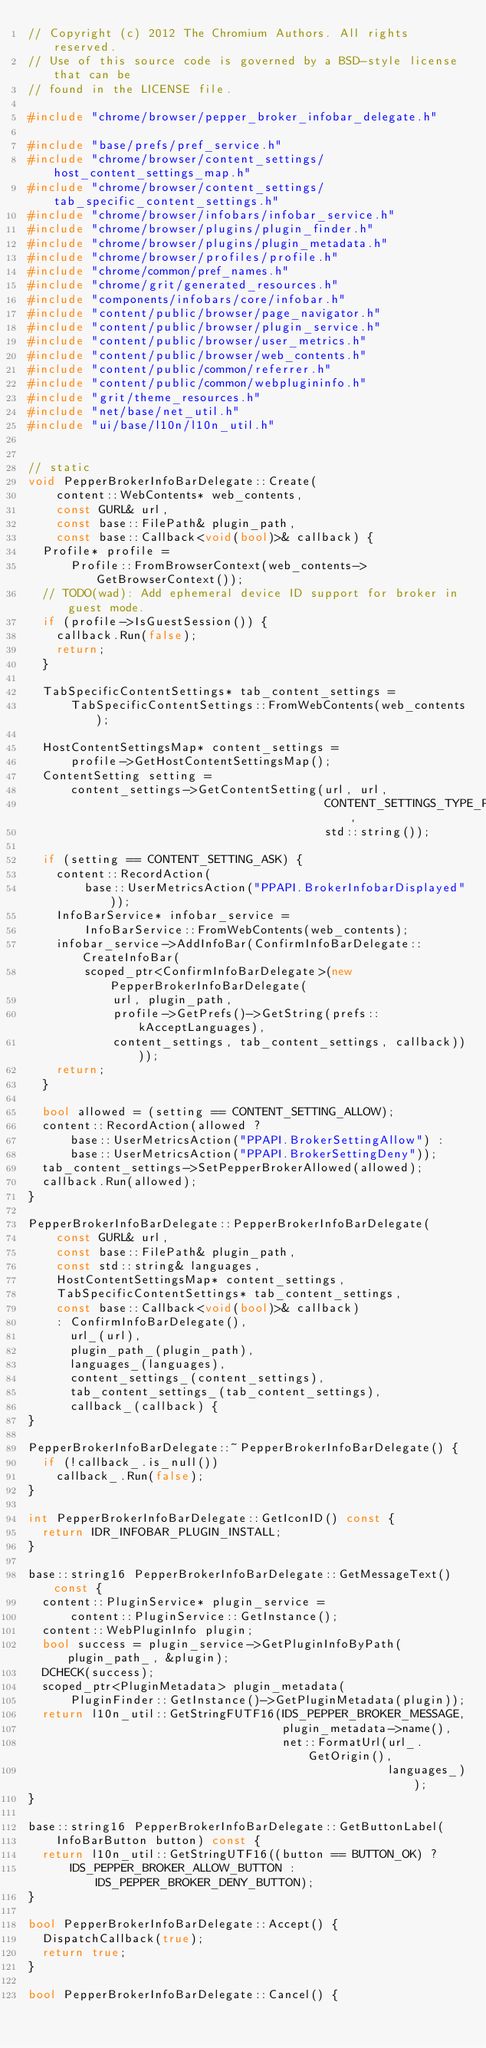Convert code to text. <code><loc_0><loc_0><loc_500><loc_500><_C++_>// Copyright (c) 2012 The Chromium Authors. All rights reserved.
// Use of this source code is governed by a BSD-style license that can be
// found in the LICENSE file.

#include "chrome/browser/pepper_broker_infobar_delegate.h"

#include "base/prefs/pref_service.h"
#include "chrome/browser/content_settings/host_content_settings_map.h"
#include "chrome/browser/content_settings/tab_specific_content_settings.h"
#include "chrome/browser/infobars/infobar_service.h"
#include "chrome/browser/plugins/plugin_finder.h"
#include "chrome/browser/plugins/plugin_metadata.h"
#include "chrome/browser/profiles/profile.h"
#include "chrome/common/pref_names.h"
#include "chrome/grit/generated_resources.h"
#include "components/infobars/core/infobar.h"
#include "content/public/browser/page_navigator.h"
#include "content/public/browser/plugin_service.h"
#include "content/public/browser/user_metrics.h"
#include "content/public/browser/web_contents.h"
#include "content/public/common/referrer.h"
#include "content/public/common/webplugininfo.h"
#include "grit/theme_resources.h"
#include "net/base/net_util.h"
#include "ui/base/l10n/l10n_util.h"


// static
void PepperBrokerInfoBarDelegate::Create(
    content::WebContents* web_contents,
    const GURL& url,
    const base::FilePath& plugin_path,
    const base::Callback<void(bool)>& callback) {
  Profile* profile =
      Profile::FromBrowserContext(web_contents->GetBrowserContext());
  // TODO(wad): Add ephemeral device ID support for broker in guest mode.
  if (profile->IsGuestSession()) {
    callback.Run(false);
    return;
  }

  TabSpecificContentSettings* tab_content_settings =
      TabSpecificContentSettings::FromWebContents(web_contents);

  HostContentSettingsMap* content_settings =
      profile->GetHostContentSettingsMap();
  ContentSetting setting =
      content_settings->GetContentSetting(url, url,
                                          CONTENT_SETTINGS_TYPE_PPAPI_BROKER,
                                          std::string());

  if (setting == CONTENT_SETTING_ASK) {
    content::RecordAction(
        base::UserMetricsAction("PPAPI.BrokerInfobarDisplayed"));
    InfoBarService* infobar_service =
        InfoBarService::FromWebContents(web_contents);
    infobar_service->AddInfoBar(ConfirmInfoBarDelegate::CreateInfoBar(
        scoped_ptr<ConfirmInfoBarDelegate>(new PepperBrokerInfoBarDelegate(
            url, plugin_path,
            profile->GetPrefs()->GetString(prefs::kAcceptLanguages),
            content_settings, tab_content_settings, callback))));
    return;
  }

  bool allowed = (setting == CONTENT_SETTING_ALLOW);
  content::RecordAction(allowed ?
      base::UserMetricsAction("PPAPI.BrokerSettingAllow") :
      base::UserMetricsAction("PPAPI.BrokerSettingDeny"));
  tab_content_settings->SetPepperBrokerAllowed(allowed);
  callback.Run(allowed);
}

PepperBrokerInfoBarDelegate::PepperBrokerInfoBarDelegate(
    const GURL& url,
    const base::FilePath& plugin_path,
    const std::string& languages,
    HostContentSettingsMap* content_settings,
    TabSpecificContentSettings* tab_content_settings,
    const base::Callback<void(bool)>& callback)
    : ConfirmInfoBarDelegate(),
      url_(url),
      plugin_path_(plugin_path),
      languages_(languages),
      content_settings_(content_settings),
      tab_content_settings_(tab_content_settings),
      callback_(callback) {
}

PepperBrokerInfoBarDelegate::~PepperBrokerInfoBarDelegate() {
  if (!callback_.is_null())
    callback_.Run(false);
}

int PepperBrokerInfoBarDelegate::GetIconID() const {
  return IDR_INFOBAR_PLUGIN_INSTALL;
}

base::string16 PepperBrokerInfoBarDelegate::GetMessageText() const {
  content::PluginService* plugin_service =
      content::PluginService::GetInstance();
  content::WebPluginInfo plugin;
  bool success = plugin_service->GetPluginInfoByPath(plugin_path_, &plugin);
  DCHECK(success);
  scoped_ptr<PluginMetadata> plugin_metadata(
      PluginFinder::GetInstance()->GetPluginMetadata(plugin));
  return l10n_util::GetStringFUTF16(IDS_PEPPER_BROKER_MESSAGE,
                                    plugin_metadata->name(),
                                    net::FormatUrl(url_.GetOrigin(),
                                                   languages_));
}

base::string16 PepperBrokerInfoBarDelegate::GetButtonLabel(
    InfoBarButton button) const {
  return l10n_util::GetStringUTF16((button == BUTTON_OK) ?
      IDS_PEPPER_BROKER_ALLOW_BUTTON : IDS_PEPPER_BROKER_DENY_BUTTON);
}

bool PepperBrokerInfoBarDelegate::Accept() {
  DispatchCallback(true);
  return true;
}

bool PepperBrokerInfoBarDelegate::Cancel() {</code> 